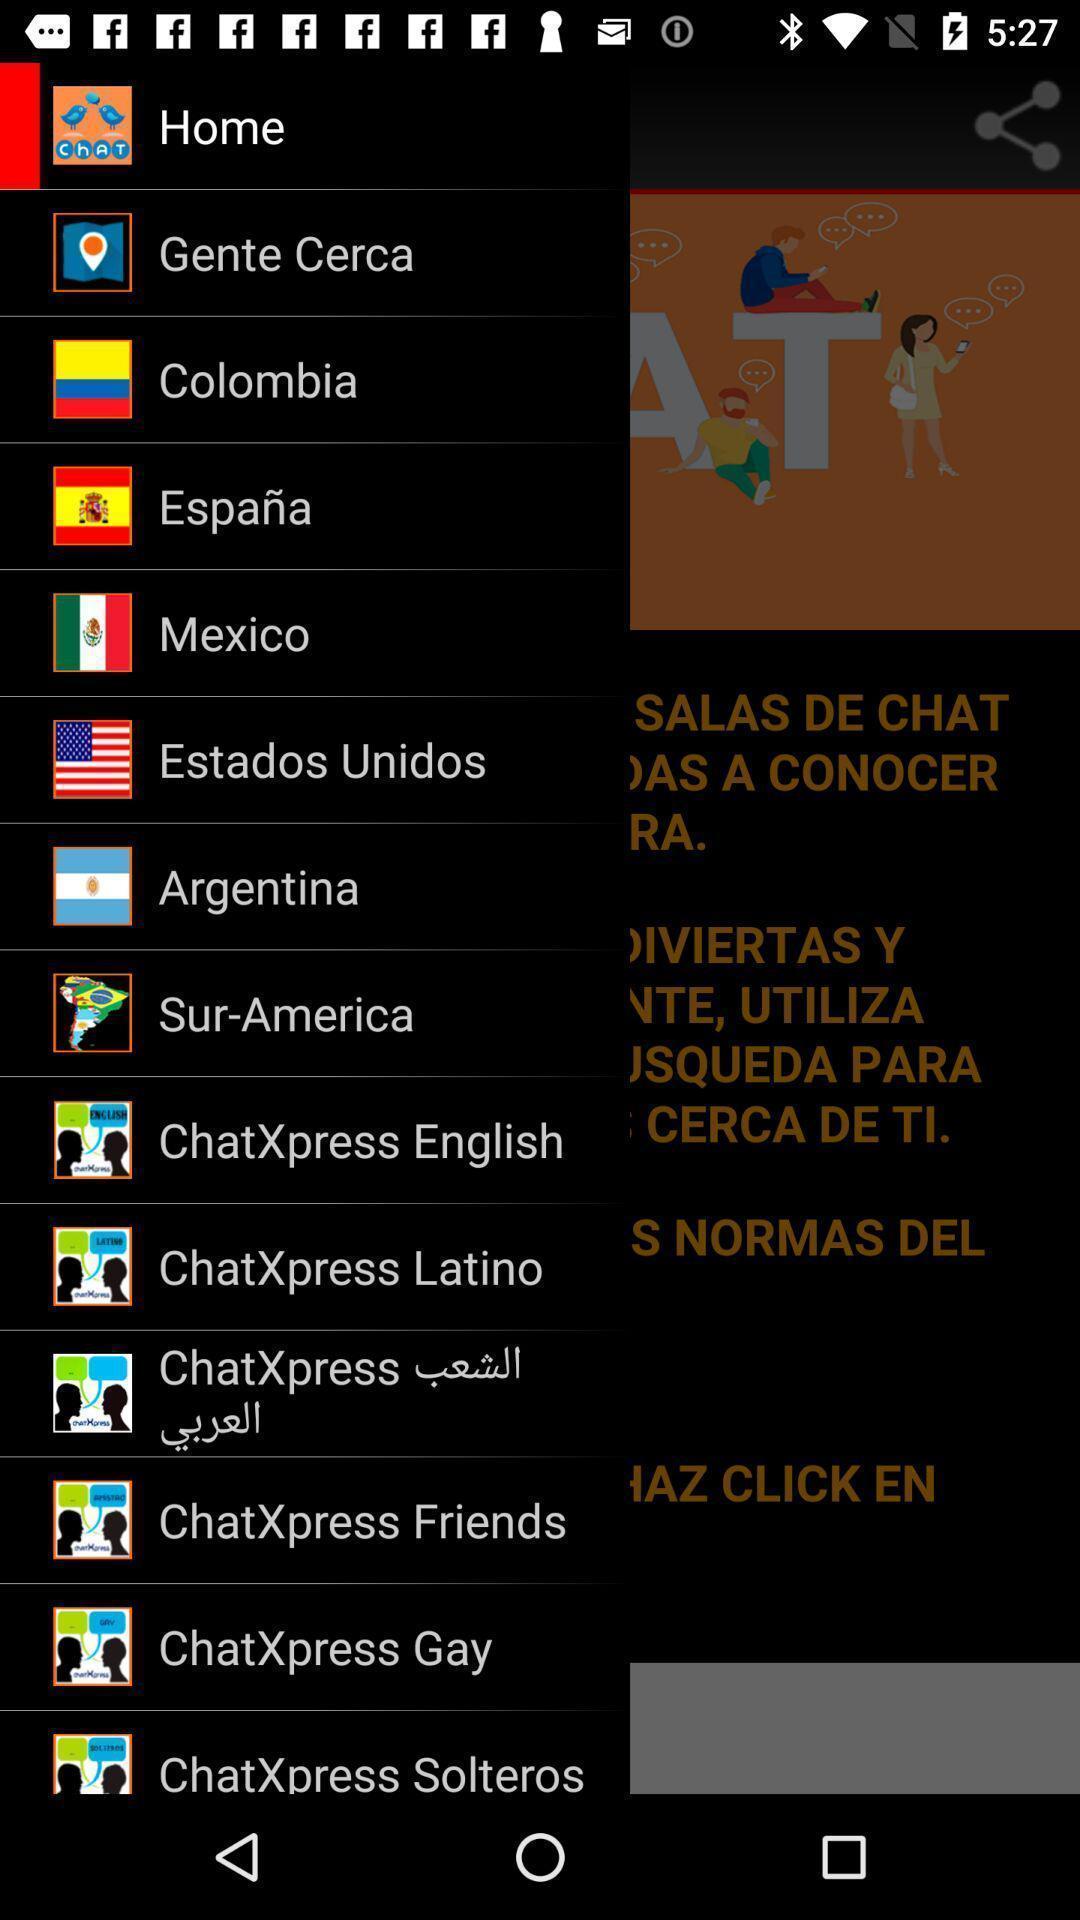Provide a description of this screenshot. Slide of various countries and options in application to select. 